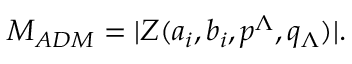Convert formula to latex. <formula><loc_0><loc_0><loc_500><loc_500>M _ { A D M } = | Z ( a _ { i } , b _ { i } , p ^ { \Lambda } , q _ { \Lambda } ) | .</formula> 